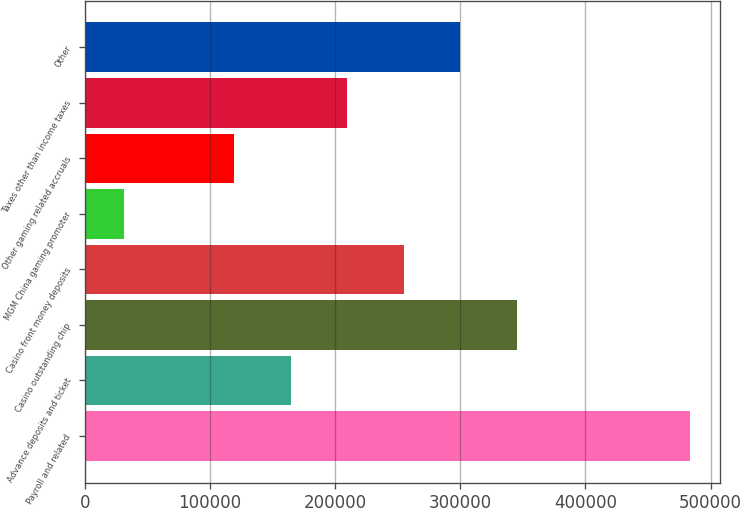<chart> <loc_0><loc_0><loc_500><loc_500><bar_chart><fcel>Payroll and related<fcel>Advance deposits and ticket<fcel>Casino outstanding chip<fcel>Casino front money deposits<fcel>MGM China gaming promoter<fcel>Other gaming related accruals<fcel>Taxes other than income taxes<fcel>Other<nl><fcel>483194<fcel>164621<fcel>345320<fcel>254971<fcel>31445<fcel>119446<fcel>209796<fcel>300146<nl></chart> 